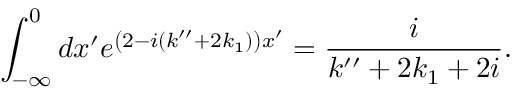Convert formula to latex. <formula><loc_0><loc_0><loc_500><loc_500>\int _ { - \infty } ^ { 0 } d x ^ { \prime } e ^ { \left ( 2 - i ( k ^ { \prime \prime } + 2 k _ { 1 } ) \right ) x ^ { \prime } } = \frac { i } { k ^ { \prime \prime } + 2 k _ { 1 } + 2 i } .</formula> 